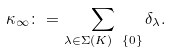Convert formula to latex. <formula><loc_0><loc_0><loc_500><loc_500>\kappa _ { \infty } \colon = \sum _ { \lambda \in \Sigma ( K ) \ \{ 0 \} } \delta _ { \lambda } .</formula> 